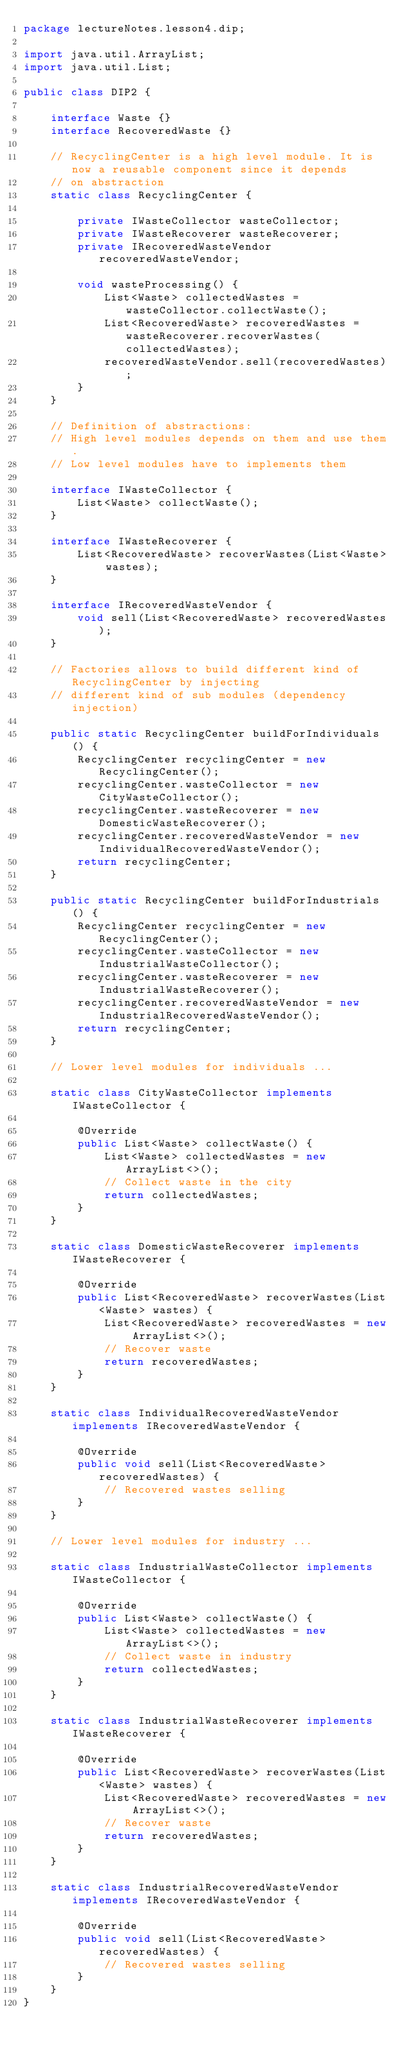<code> <loc_0><loc_0><loc_500><loc_500><_Java_>package lectureNotes.lesson4.dip;

import java.util.ArrayList;
import java.util.List;

public class DIP2 {

    interface Waste {}
    interface RecoveredWaste {}
    
    // RecyclingCenter is a high level module. It is now a reusable component since it depends
    // on abstraction
    static class RecyclingCenter {
        
        private IWasteCollector wasteCollector;
        private IWasteRecoverer wasteRecoverer;
        private IRecoveredWasteVendor recoveredWasteVendor;
        
        void wasteProcessing() {
            List<Waste> collectedWastes = wasteCollector.collectWaste();
            List<RecoveredWaste> recoveredWastes = wasteRecoverer.recoverWastes(collectedWastes);
            recoveredWasteVendor.sell(recoveredWastes);
        }
    }
    
    // Definition of abstractions:
    // High level modules depends on them and use them.
    // Low level modules have to implements them
    
    interface IWasteCollector {
        List<Waste> collectWaste();
    }
    
    interface IWasteRecoverer {
        List<RecoveredWaste> recoverWastes(List<Waste> wastes);
    }
    
    interface IRecoveredWasteVendor {
        void sell(List<RecoveredWaste> recoveredWastes);
    }
    
    // Factories allows to build different kind of RecyclingCenter by injecting
    // different kind of sub modules (dependency injection)
    
    public static RecyclingCenter buildForIndividuals() {
        RecyclingCenter recyclingCenter = new RecyclingCenter();
        recyclingCenter.wasteCollector = new CityWasteCollector();
        recyclingCenter.wasteRecoverer = new DomesticWasteRecoverer();
        recyclingCenter.recoveredWasteVendor = new IndividualRecoveredWasteVendor();
        return recyclingCenter;
    }
    
    public static RecyclingCenter buildForIndustrials() {
        RecyclingCenter recyclingCenter = new RecyclingCenter();
        recyclingCenter.wasteCollector = new IndustrialWasteCollector();
        recyclingCenter.wasteRecoverer = new IndustrialWasteRecoverer();
        recyclingCenter.recoveredWasteVendor = new IndustrialRecoveredWasteVendor();
        return recyclingCenter;
    }
    
    // Lower level modules for individuals ...
    
    static class CityWasteCollector implements IWasteCollector {
        
        @Override
        public List<Waste> collectWaste() {
            List<Waste> collectedWastes = new ArrayList<>();
            // Collect waste in the city
            return collectedWastes;
        }
    }
    
    static class DomesticWasteRecoverer implements IWasteRecoverer {
        
        @Override
        public List<RecoveredWaste> recoverWastes(List<Waste> wastes) {
            List<RecoveredWaste> recoveredWastes = new ArrayList<>();
            // Recover waste
            return recoveredWastes;
        }
    }
    
    static class IndividualRecoveredWasteVendor implements IRecoveredWasteVendor {
        
        @Override
        public void sell(List<RecoveredWaste> recoveredWastes) {
            // Recovered wastes selling
        }
    }
    
    // Lower level modules for industry ...
    
    static class IndustrialWasteCollector implements IWasteCollector {
        
        @Override
        public List<Waste> collectWaste() {
            List<Waste> collectedWastes = new ArrayList<>();
            // Collect waste in industry
            return collectedWastes;
        }
    }
    
    static class IndustrialWasteRecoverer implements IWasteRecoverer {
        
        @Override
        public List<RecoveredWaste> recoverWastes(List<Waste> wastes) {
            List<RecoveredWaste> recoveredWastes = new ArrayList<>();
            // Recover waste
            return recoveredWastes;
        }
    }
    
    static class IndustrialRecoveredWasteVendor implements IRecoveredWasteVendor {
        
        @Override
        public void sell(List<RecoveredWaste> recoveredWastes) {
            // Recovered wastes selling
        }
    }
}
</code> 